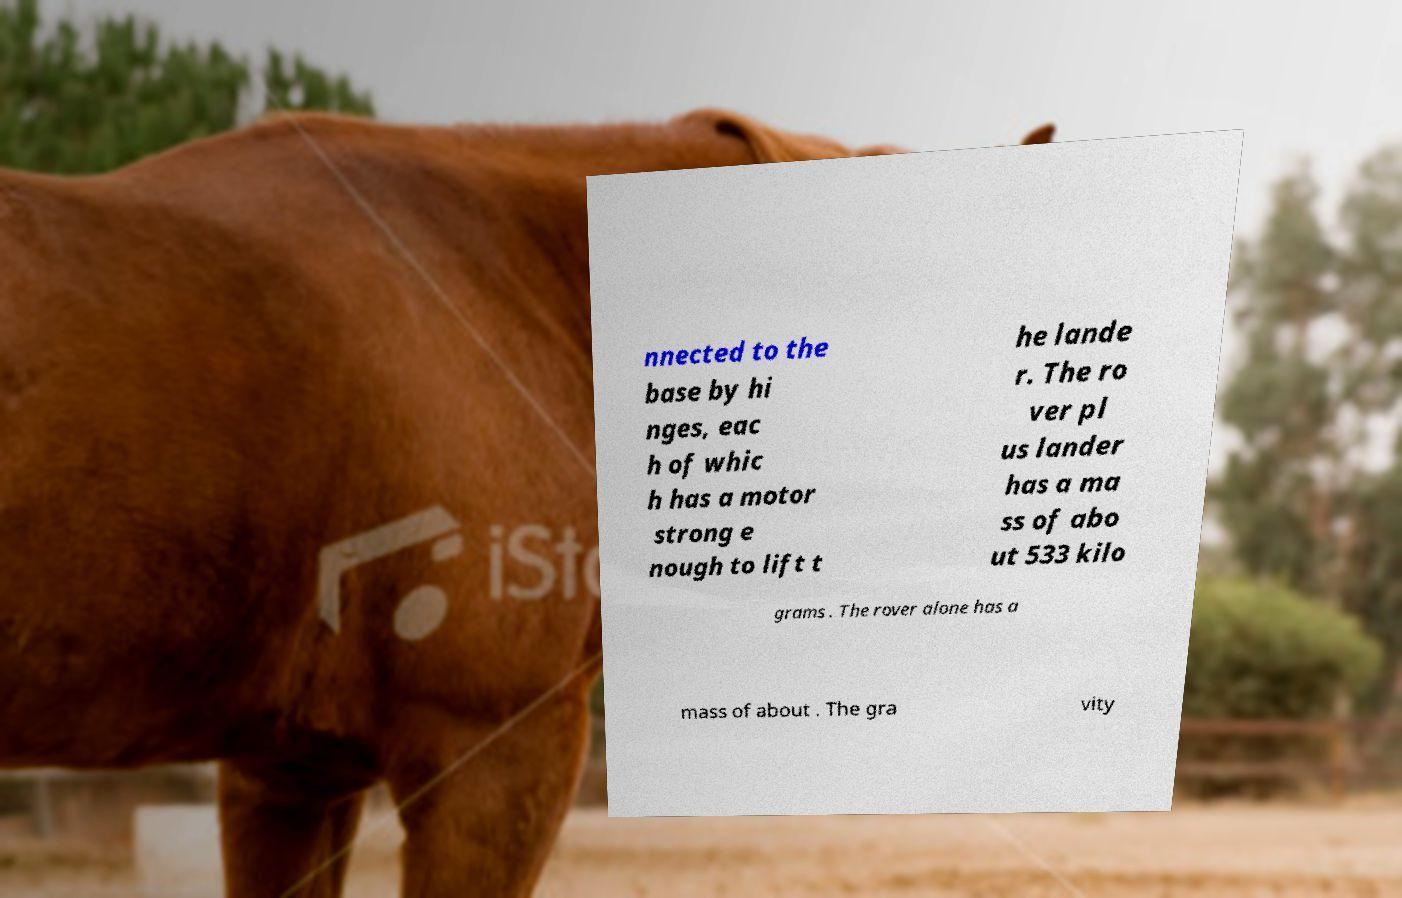Can you read and provide the text displayed in the image?This photo seems to have some interesting text. Can you extract and type it out for me? nnected to the base by hi nges, eac h of whic h has a motor strong e nough to lift t he lande r. The ro ver pl us lander has a ma ss of abo ut 533 kilo grams . The rover alone has a mass of about . The gra vity 